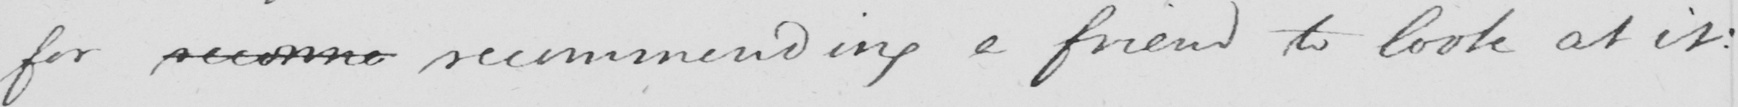What is written in this line of handwriting? for reconne recommending a friend to look at it : 